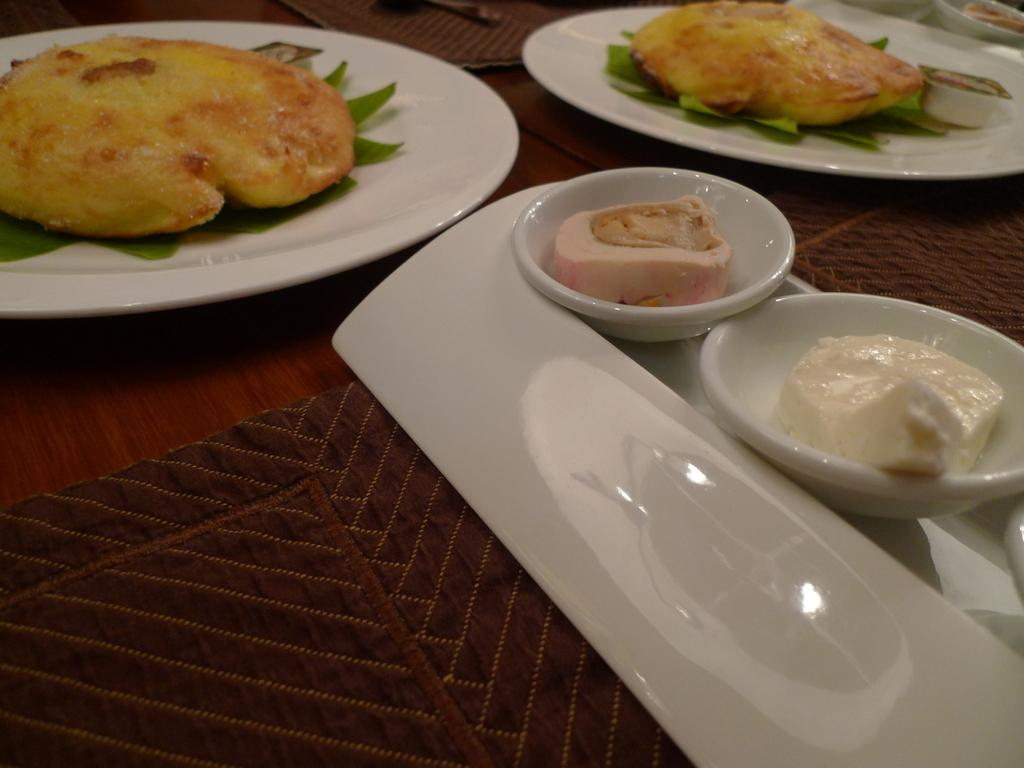What type of items can be seen in the image? There are food items and other objects in the image. Can you describe the table in the image? The wooden table is present in the image. What type of work is being done with the apparatus in the image? There is no apparatus present in the image, so it is not possible to answer that question. 